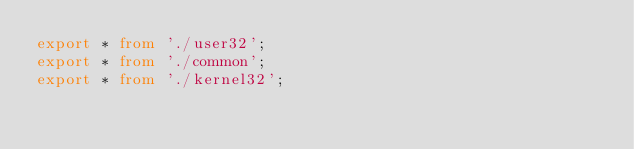Convert code to text. <code><loc_0><loc_0><loc_500><loc_500><_TypeScript_>export * from './user32';
export * from './common';
export * from './kernel32';
</code> 